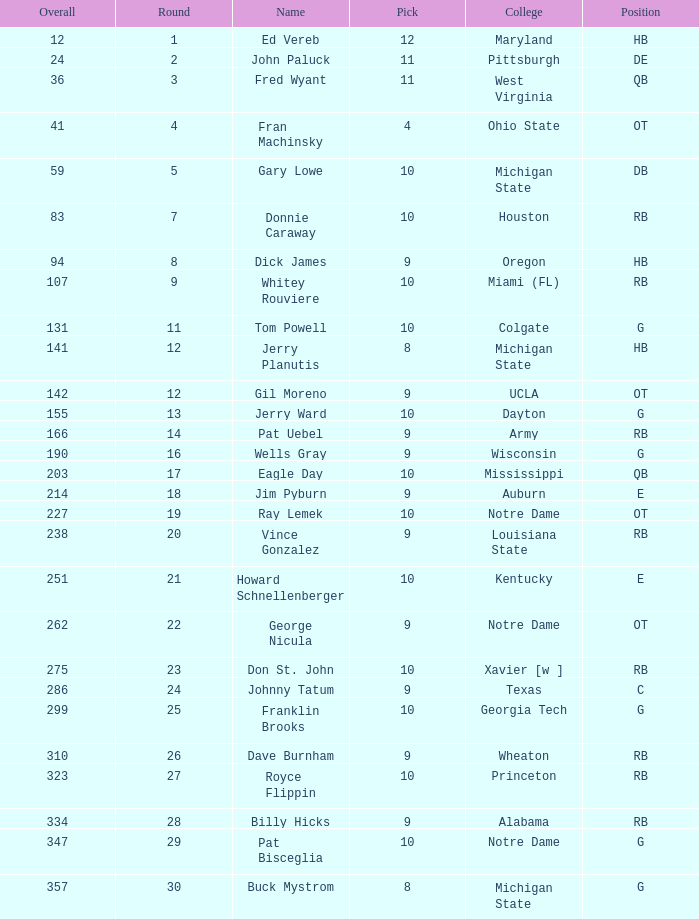What is the overall pick number for a draft pick smaller than 9, named buck mystrom from Michigan State college? 357.0. 